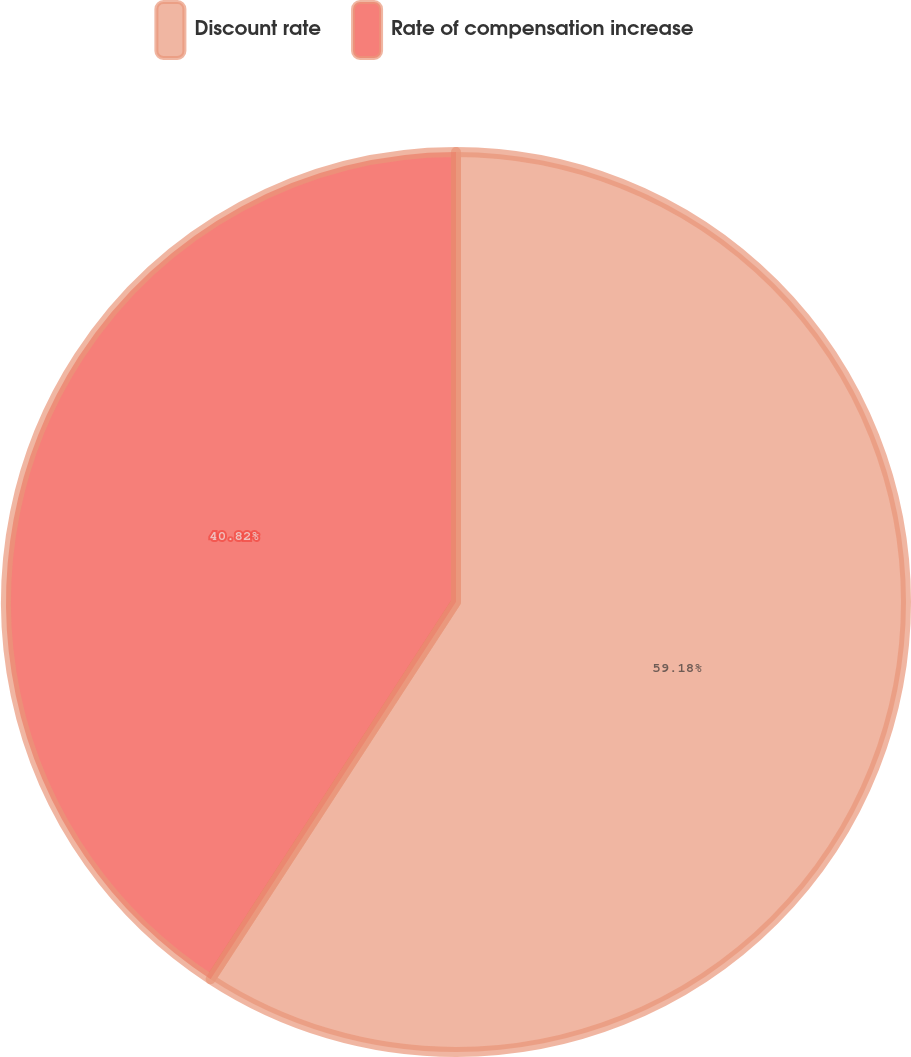Convert chart. <chart><loc_0><loc_0><loc_500><loc_500><pie_chart><fcel>Discount rate<fcel>Rate of compensation increase<nl><fcel>59.18%<fcel>40.82%<nl></chart> 